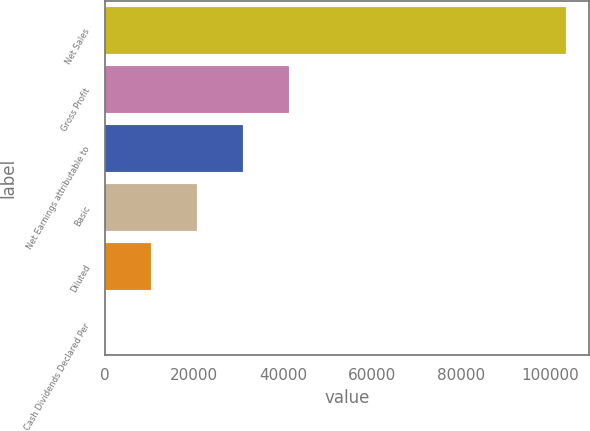<chart> <loc_0><loc_0><loc_500><loc_500><bar_chart><fcel>Net Sales<fcel>Gross Profit<fcel>Net Earnings attributable to<fcel>Basic<fcel>Diluted<fcel>Cash Dividends Declared Per<nl><fcel>103444<fcel>41378.4<fcel>31034.2<fcel>20689.9<fcel>10345.6<fcel>1.37<nl></chart> 